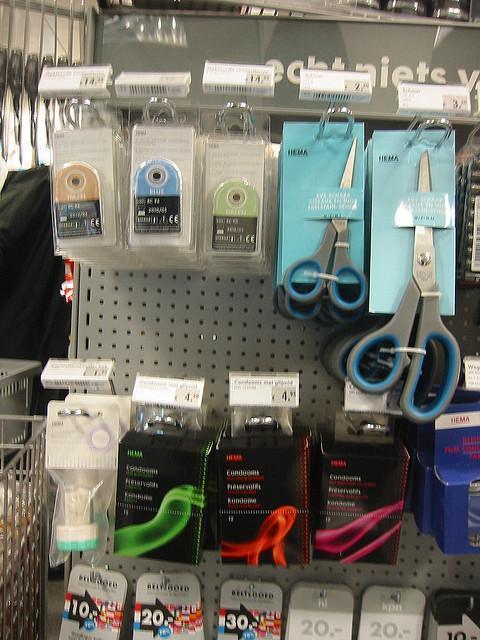How many scissors are there?
Give a very brief answer. 2. How many doors does the red car have?
Give a very brief answer. 0. 